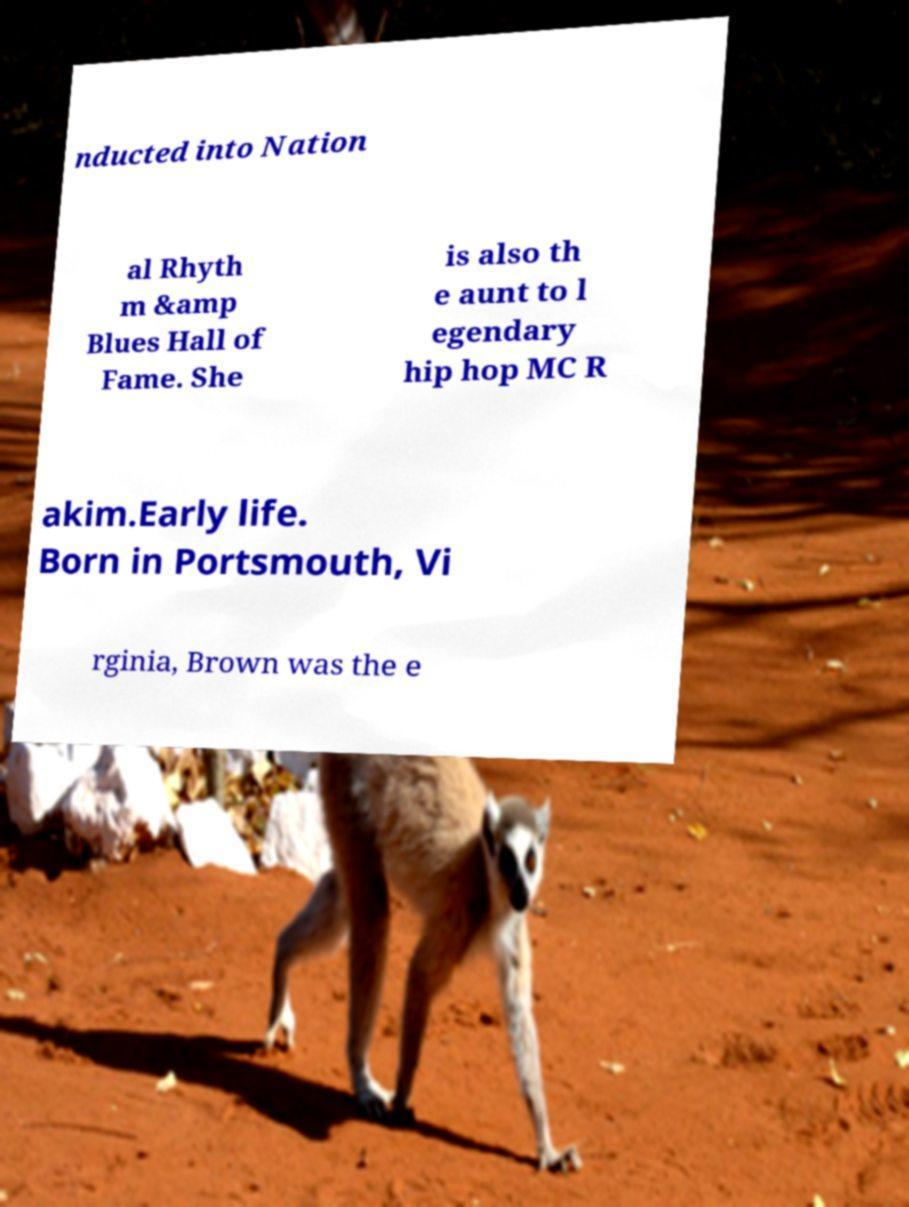For documentation purposes, I need the text within this image transcribed. Could you provide that? nducted into Nation al Rhyth m &amp Blues Hall of Fame. She is also th e aunt to l egendary hip hop MC R akim.Early life. Born in Portsmouth, Vi rginia, Brown was the e 